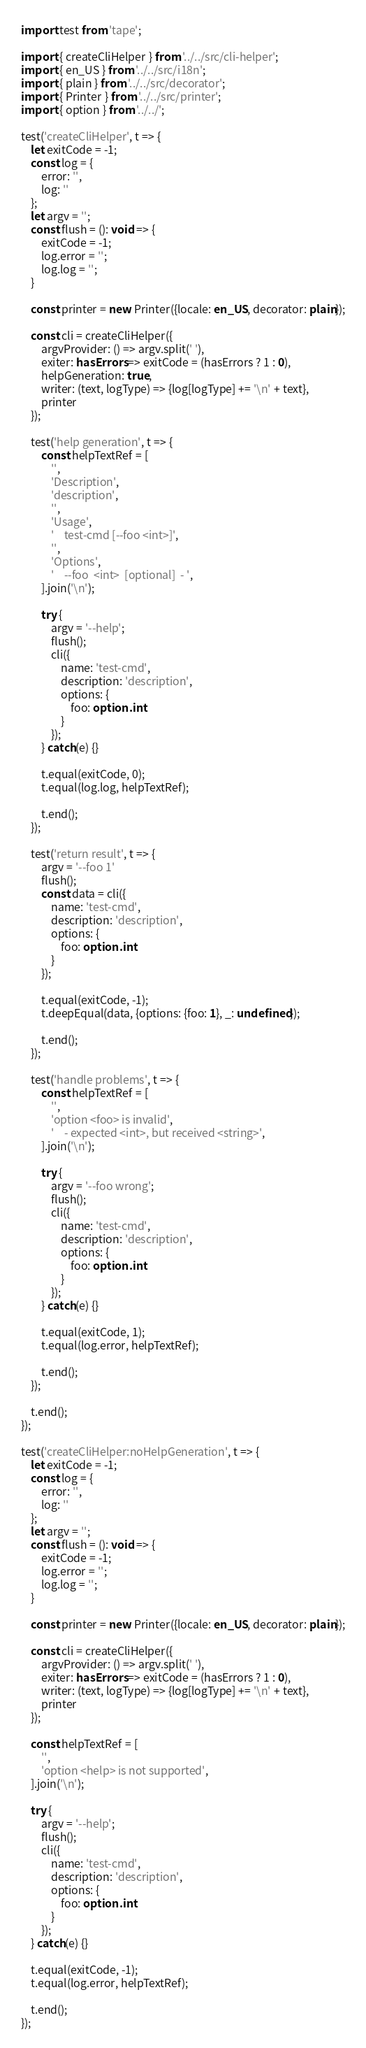<code> <loc_0><loc_0><loc_500><loc_500><_TypeScript_>import test from 'tape';

import { createCliHelper } from '../../src/cli-helper';
import { en_US } from '../../src/i18n';
import { plain } from '../../src/decorator';
import { Printer } from '../../src/printer';
import { option } from '../../';

test('createCliHelper', t => {
    let exitCode = -1;
    const log = {
        error: '',
        log: ''
    };
    let argv = '';
    const flush = (): void => {
        exitCode = -1;
        log.error = '';
        log.log = '';
    }

    const printer = new Printer({locale: en_US, decorator: plain});

    const cli = createCliHelper({
        argvProvider: () => argv.split(' '),
        exiter: hasErrors => exitCode = (hasErrors ? 1 : 0),
        helpGeneration: true,
        writer: (text, logType) => {log[logType] += '\n' + text},
        printer
    });

    test('help generation', t => {
        const helpTextRef = [
            '',
            'Description',
            'description',
            '',
            'Usage',
            '    test-cmd [--foo <int>]',
            '',
            'Options',
            '    --foo  <int>  [optional]  - ',
        ].join('\n');

        try {
            argv = '--help';
            flush();
            cli({
                name: 'test-cmd',
                description: 'description',
                options: {
                    foo: option.int
                }
            });
        } catch(e) {}

        t.equal(exitCode, 0);
        t.equal(log.log, helpTextRef);

        t.end();
    });

    test('return result', t => {
        argv = '--foo 1'
        flush();
        const data = cli({
            name: 'test-cmd',
            description: 'description',
            options: {
                foo: option.int
            }
        });

        t.equal(exitCode, -1);
        t.deepEqual(data, {options: {foo: 1}, _: undefined});

        t.end();
    });

    test('handle problems', t => {
        const helpTextRef = [
            '',
            'option <foo> is invalid',
            '    - expected <int>, but received <string>',
        ].join('\n');

        try {
            argv = '--foo wrong';
            flush();
            cli({
                name: 'test-cmd',
                description: 'description',
                options: {
                    foo: option.int
                }
            });
        } catch(e) {}

        t.equal(exitCode, 1);
        t.equal(log.error, helpTextRef);

        t.end();
    });

    t.end();
});

test('createCliHelper:noHelpGeneration', t => {
    let exitCode = -1;
    const log = {
        error: '',
        log: ''
    };
    let argv = '';
    const flush = (): void => {
        exitCode = -1;
        log.error = '';
        log.log = '';
    }

    const printer = new Printer({locale: en_US, decorator: plain});

    const cli = createCliHelper({
        argvProvider: () => argv.split(' '),
        exiter: hasErrors => exitCode = (hasErrors ? 1 : 0),
        writer: (text, logType) => {log[logType] += '\n' + text},
        printer
    });

    const helpTextRef = [
        '',
        'option <help> is not supported',
    ].join('\n');

    try {
        argv = '--help';
        flush();
        cli({
            name: 'test-cmd',
            description: 'description',
            options: {
                foo: option.int
            }
        });
    } catch(e) {}

    t.equal(exitCode, -1);
    t.equal(log.error, helpTextRef);

    t.end();
});
</code> 